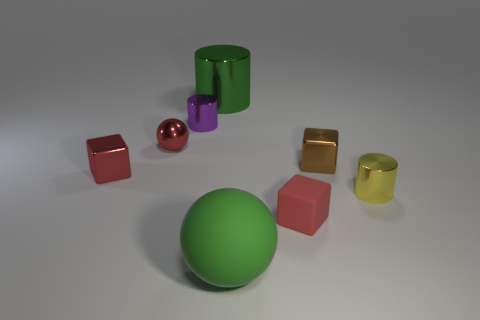Does the green shiny object have the same shape as the small purple object?
Your response must be concise. Yes. What is the shape of the other large thing that is the same color as the big matte object?
Offer a very short reply. Cylinder. Are there any other big things that have the same color as the large matte thing?
Provide a short and direct response. Yes. Is there a red shiny ball that is in front of the tiny cube that is behind the metallic cube to the left of the small matte block?
Ensure brevity in your answer.  No. Are there more yellow things in front of the small brown metallic cube than small green blocks?
Provide a short and direct response. Yes. Is the shape of the small purple metal thing behind the yellow shiny object the same as  the small yellow shiny object?
Provide a succinct answer. Yes. What number of things are either green metallic cylinders or tiny things that are on the left side of the small yellow cylinder?
Your answer should be compact. 6. What size is the object that is on the right side of the big matte object and behind the yellow object?
Make the answer very short. Small. Are there more shiny things that are to the left of the yellow cylinder than purple cylinders left of the small red sphere?
Your response must be concise. Yes. There is a large matte thing; is it the same shape as the red metallic object behind the small brown cube?
Ensure brevity in your answer.  Yes. 